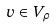<formula> <loc_0><loc_0><loc_500><loc_500>v \in V _ { \rho }</formula> 